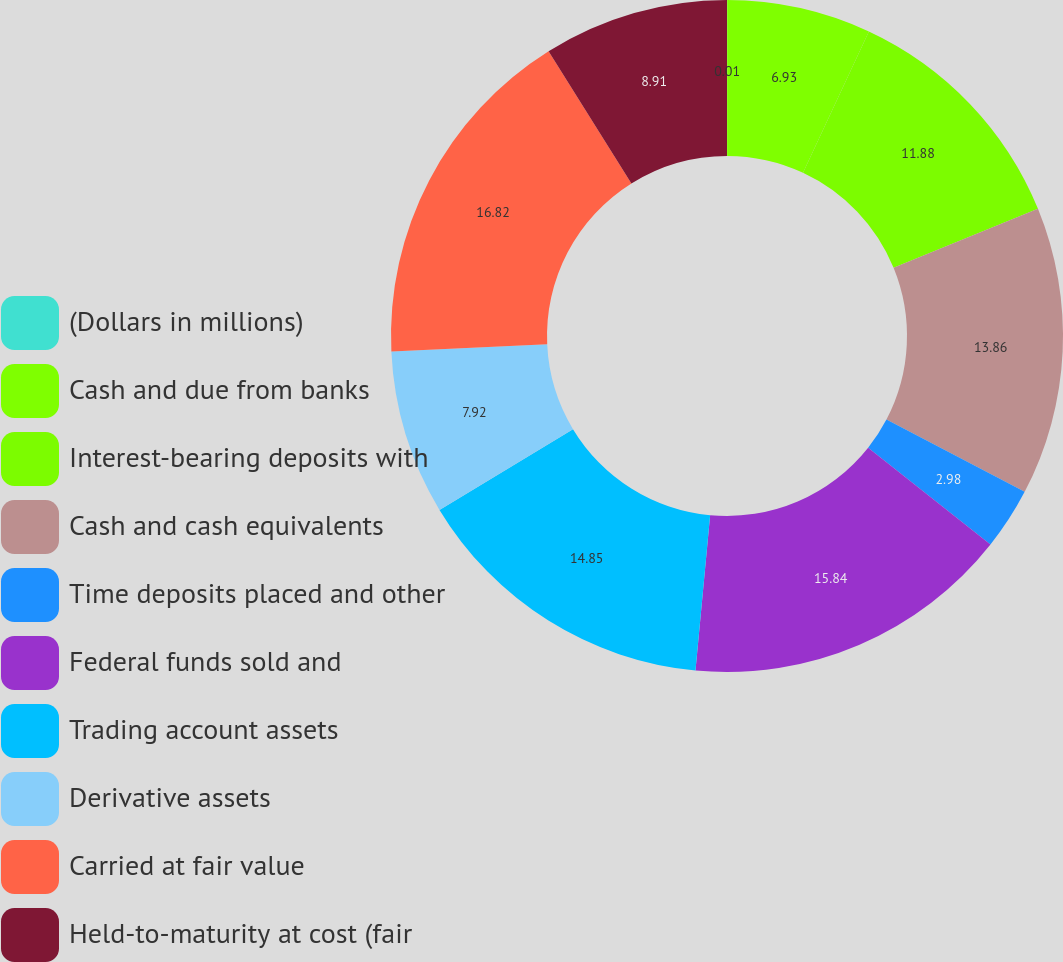<chart> <loc_0><loc_0><loc_500><loc_500><pie_chart><fcel>(Dollars in millions)<fcel>Cash and due from banks<fcel>Interest-bearing deposits with<fcel>Cash and cash equivalents<fcel>Time deposits placed and other<fcel>Federal funds sold and<fcel>Trading account assets<fcel>Derivative assets<fcel>Carried at fair value<fcel>Held-to-maturity at cost (fair<nl><fcel>0.01%<fcel>6.93%<fcel>11.88%<fcel>13.86%<fcel>2.98%<fcel>15.84%<fcel>14.85%<fcel>7.92%<fcel>16.83%<fcel>8.91%<nl></chart> 